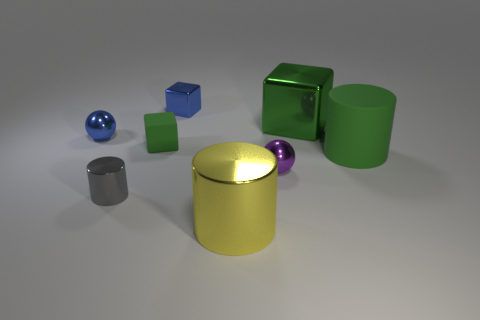There is a big green object that is the same shape as the small green object; what is it made of?
Offer a very short reply. Metal. There is a cylinder that is to the left of the large green metallic object and to the right of the small metallic cylinder; what material is it?
Offer a very short reply. Metal. Are there fewer large matte cylinders left of the big cube than shiny blocks that are in front of the yellow object?
Keep it short and to the point. No. How many other things are the same size as the yellow metal cylinder?
Your response must be concise. 2. There is a rubber object on the left side of the big metal thing that is in front of the cylinder that is right of the big yellow object; what shape is it?
Ensure brevity in your answer.  Cube. What number of blue things are either matte blocks or tiny blocks?
Provide a short and direct response. 1. There is a large metallic thing that is behind the green cylinder; how many tiny matte cubes are to the right of it?
Keep it short and to the point. 0. Is there anything else of the same color as the tiny metal cylinder?
Provide a succinct answer. No. There is a green thing that is made of the same material as the gray cylinder; what shape is it?
Give a very brief answer. Cube. Is the color of the small cylinder the same as the matte cylinder?
Offer a terse response. No. 